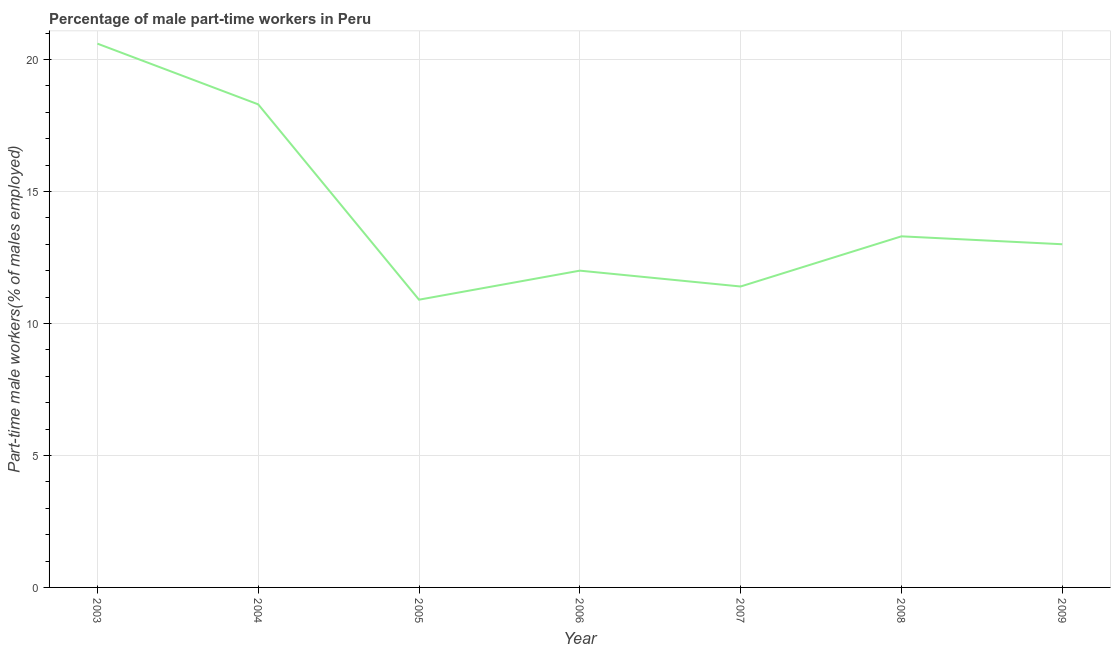What is the percentage of part-time male workers in 2004?
Provide a short and direct response. 18.3. Across all years, what is the maximum percentage of part-time male workers?
Keep it short and to the point. 20.6. Across all years, what is the minimum percentage of part-time male workers?
Give a very brief answer. 10.9. What is the sum of the percentage of part-time male workers?
Offer a very short reply. 99.5. What is the difference between the percentage of part-time male workers in 2006 and 2007?
Your answer should be very brief. 0.6. What is the average percentage of part-time male workers per year?
Make the answer very short. 14.21. What is the ratio of the percentage of part-time male workers in 2007 to that in 2008?
Keep it short and to the point. 0.86. Is the percentage of part-time male workers in 2007 less than that in 2008?
Your response must be concise. Yes. Is the difference between the percentage of part-time male workers in 2004 and 2009 greater than the difference between any two years?
Ensure brevity in your answer.  No. What is the difference between the highest and the second highest percentage of part-time male workers?
Provide a succinct answer. 2.3. What is the difference between the highest and the lowest percentage of part-time male workers?
Offer a very short reply. 9.7. In how many years, is the percentage of part-time male workers greater than the average percentage of part-time male workers taken over all years?
Offer a very short reply. 2. How many lines are there?
Your answer should be very brief. 1. What is the difference between two consecutive major ticks on the Y-axis?
Your response must be concise. 5. What is the title of the graph?
Provide a short and direct response. Percentage of male part-time workers in Peru. What is the label or title of the Y-axis?
Ensure brevity in your answer.  Part-time male workers(% of males employed). What is the Part-time male workers(% of males employed) of 2003?
Keep it short and to the point. 20.6. What is the Part-time male workers(% of males employed) of 2004?
Ensure brevity in your answer.  18.3. What is the Part-time male workers(% of males employed) in 2005?
Your response must be concise. 10.9. What is the Part-time male workers(% of males employed) in 2006?
Give a very brief answer. 12. What is the Part-time male workers(% of males employed) of 2007?
Give a very brief answer. 11.4. What is the Part-time male workers(% of males employed) in 2008?
Offer a very short reply. 13.3. What is the Part-time male workers(% of males employed) of 2009?
Your answer should be compact. 13. What is the difference between the Part-time male workers(% of males employed) in 2003 and 2005?
Ensure brevity in your answer.  9.7. What is the difference between the Part-time male workers(% of males employed) in 2003 and 2006?
Ensure brevity in your answer.  8.6. What is the difference between the Part-time male workers(% of males employed) in 2003 and 2007?
Give a very brief answer. 9.2. What is the difference between the Part-time male workers(% of males employed) in 2004 and 2006?
Ensure brevity in your answer.  6.3. What is the difference between the Part-time male workers(% of males employed) in 2004 and 2007?
Ensure brevity in your answer.  6.9. What is the difference between the Part-time male workers(% of males employed) in 2004 and 2009?
Make the answer very short. 5.3. What is the difference between the Part-time male workers(% of males employed) in 2005 and 2007?
Offer a terse response. -0.5. What is the difference between the Part-time male workers(% of males employed) in 2005 and 2009?
Ensure brevity in your answer.  -2.1. What is the difference between the Part-time male workers(% of males employed) in 2007 and 2008?
Your answer should be compact. -1.9. What is the ratio of the Part-time male workers(% of males employed) in 2003 to that in 2004?
Provide a succinct answer. 1.13. What is the ratio of the Part-time male workers(% of males employed) in 2003 to that in 2005?
Keep it short and to the point. 1.89. What is the ratio of the Part-time male workers(% of males employed) in 2003 to that in 2006?
Provide a short and direct response. 1.72. What is the ratio of the Part-time male workers(% of males employed) in 2003 to that in 2007?
Your answer should be very brief. 1.81. What is the ratio of the Part-time male workers(% of males employed) in 2003 to that in 2008?
Your answer should be compact. 1.55. What is the ratio of the Part-time male workers(% of males employed) in 2003 to that in 2009?
Offer a terse response. 1.58. What is the ratio of the Part-time male workers(% of males employed) in 2004 to that in 2005?
Your answer should be very brief. 1.68. What is the ratio of the Part-time male workers(% of males employed) in 2004 to that in 2006?
Your response must be concise. 1.52. What is the ratio of the Part-time male workers(% of males employed) in 2004 to that in 2007?
Your answer should be compact. 1.6. What is the ratio of the Part-time male workers(% of males employed) in 2004 to that in 2008?
Provide a succinct answer. 1.38. What is the ratio of the Part-time male workers(% of males employed) in 2004 to that in 2009?
Ensure brevity in your answer.  1.41. What is the ratio of the Part-time male workers(% of males employed) in 2005 to that in 2006?
Provide a short and direct response. 0.91. What is the ratio of the Part-time male workers(% of males employed) in 2005 to that in 2007?
Provide a short and direct response. 0.96. What is the ratio of the Part-time male workers(% of males employed) in 2005 to that in 2008?
Your answer should be very brief. 0.82. What is the ratio of the Part-time male workers(% of males employed) in 2005 to that in 2009?
Provide a succinct answer. 0.84. What is the ratio of the Part-time male workers(% of males employed) in 2006 to that in 2007?
Ensure brevity in your answer.  1.05. What is the ratio of the Part-time male workers(% of males employed) in 2006 to that in 2008?
Your answer should be compact. 0.9. What is the ratio of the Part-time male workers(% of males employed) in 2006 to that in 2009?
Offer a very short reply. 0.92. What is the ratio of the Part-time male workers(% of males employed) in 2007 to that in 2008?
Keep it short and to the point. 0.86. What is the ratio of the Part-time male workers(% of males employed) in 2007 to that in 2009?
Offer a very short reply. 0.88. What is the ratio of the Part-time male workers(% of males employed) in 2008 to that in 2009?
Offer a very short reply. 1.02. 